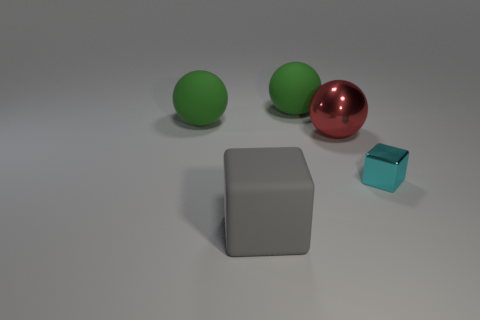What size is the metallic object in front of the metallic object left of the object that is right of the metal sphere?
Your answer should be compact. Small. Does the small metal block have the same color as the matte cube?
Your response must be concise. No. Are there any other things that are the same size as the cyan thing?
Provide a short and direct response. No. How many big metal things are on the left side of the big gray matte thing?
Give a very brief answer. 0. Are there an equal number of cyan shiny cubes behind the large red shiny sphere and large gray metal balls?
Provide a short and direct response. Yes. How many things are either big cyan metal balls or large matte blocks?
Offer a terse response. 1. Is there any other thing that is the same shape as the large red thing?
Give a very brief answer. Yes. There is a green rubber object that is left of the rubber thing in front of the red sphere; what shape is it?
Give a very brief answer. Sphere. What is the shape of the thing that is made of the same material as the small cyan cube?
Your answer should be compact. Sphere. There is a matte thing left of the rubber thing in front of the big red sphere; what is its size?
Provide a succinct answer. Large. 